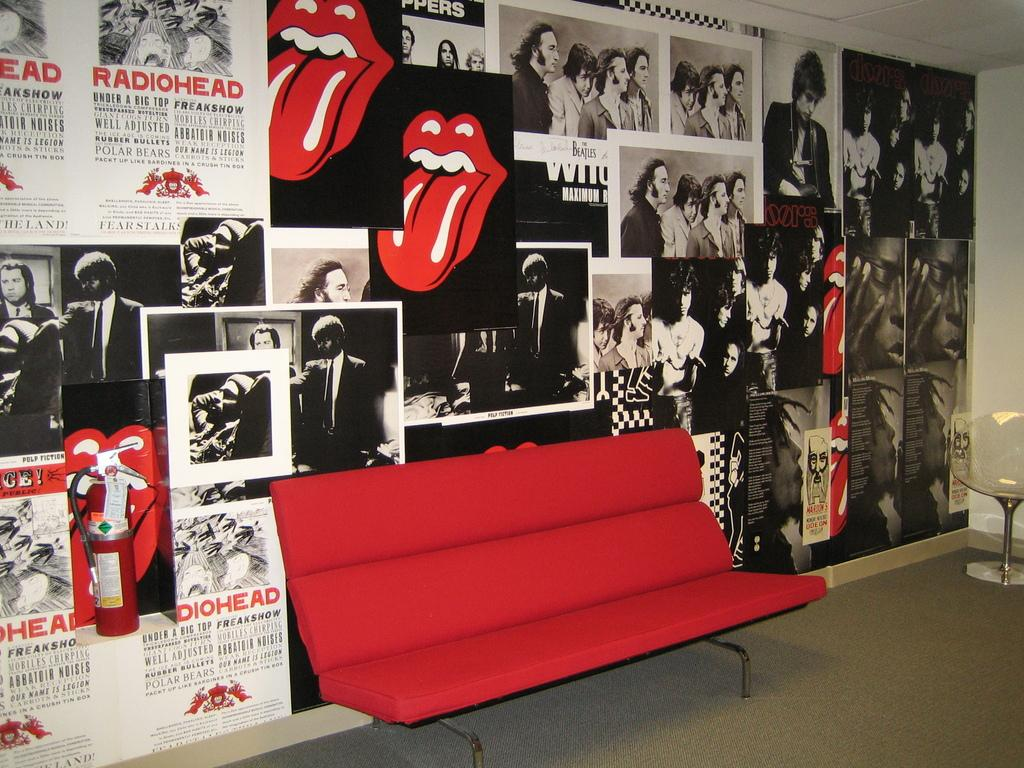What type of decoration is on the wall in the image? There are black and white pictures of different people on the wall. Can you describe the subjects of the pictures? The pictures are of different people. What piece of furniture is in the middle of the image? There is a red sofa chair in the middle of the image. What type of polish is being applied to the flower in the image? There is no flower or polish present in the image. What is the cause of death for the person in the image? There is no indication of death or a person in the image. 